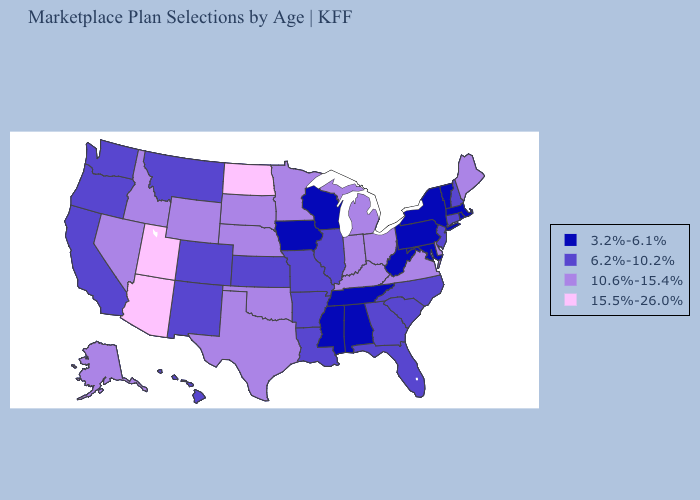What is the value of Montana?
Short answer required. 6.2%-10.2%. Does Alabama have the same value as Iowa?
Write a very short answer. Yes. Name the states that have a value in the range 15.5%-26.0%?
Answer briefly. Arizona, North Dakota, Utah. Does Kansas have the lowest value in the USA?
Quick response, please. No. What is the lowest value in the South?
Quick response, please. 3.2%-6.1%. Does Oregon have the lowest value in the West?
Give a very brief answer. Yes. What is the value of Alaska?
Keep it brief. 10.6%-15.4%. What is the lowest value in the South?
Keep it brief. 3.2%-6.1%. Does New York have the lowest value in the Northeast?
Answer briefly. Yes. Is the legend a continuous bar?
Be succinct. No. What is the value of New York?
Concise answer only. 3.2%-6.1%. Name the states that have a value in the range 6.2%-10.2%?
Short answer required. Arkansas, California, Colorado, Connecticut, Florida, Georgia, Hawaii, Illinois, Kansas, Louisiana, Missouri, Montana, New Hampshire, New Jersey, New Mexico, North Carolina, Oregon, South Carolina, Washington. Name the states that have a value in the range 15.5%-26.0%?
Give a very brief answer. Arizona, North Dakota, Utah. What is the value of Utah?
Concise answer only. 15.5%-26.0%. Among the states that border Delaware , which have the lowest value?
Give a very brief answer. Maryland, Pennsylvania. 